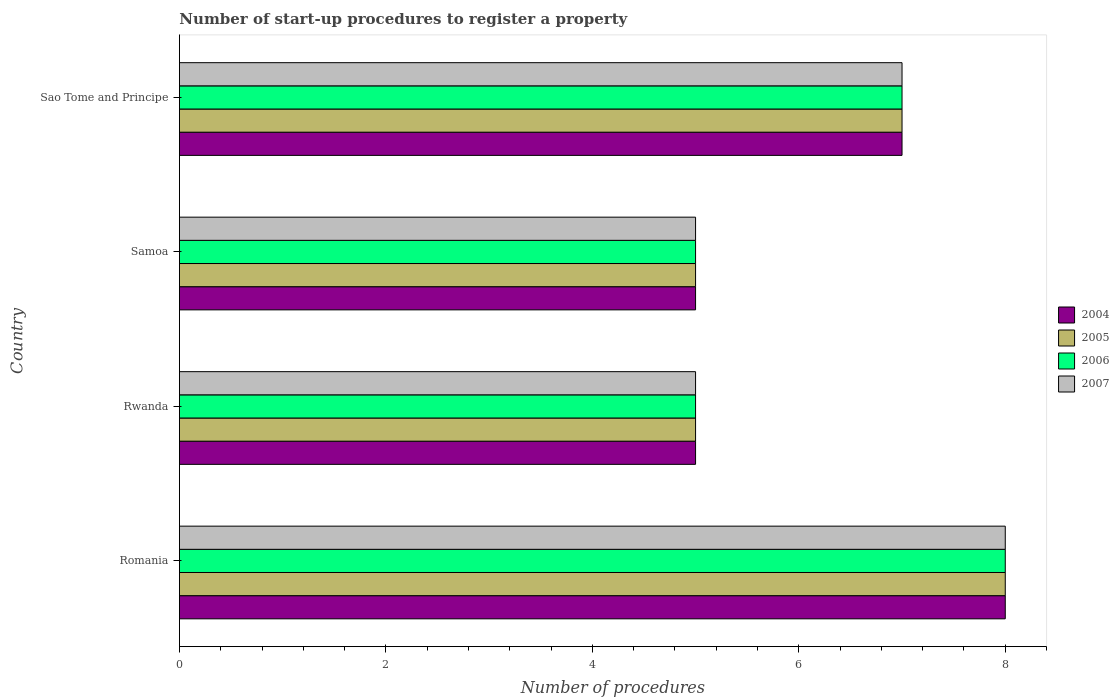How many different coloured bars are there?
Ensure brevity in your answer.  4. Are the number of bars on each tick of the Y-axis equal?
Make the answer very short. Yes. What is the label of the 4th group of bars from the top?
Give a very brief answer. Romania. Across all countries, what is the maximum number of procedures required to register a property in 2004?
Your answer should be compact. 8. Across all countries, what is the minimum number of procedures required to register a property in 2007?
Offer a very short reply. 5. In which country was the number of procedures required to register a property in 2004 maximum?
Give a very brief answer. Romania. In which country was the number of procedures required to register a property in 2007 minimum?
Keep it short and to the point. Rwanda. What is the total number of procedures required to register a property in 2005 in the graph?
Your answer should be compact. 25. What is the average number of procedures required to register a property in 2004 per country?
Your answer should be compact. 6.25. What is the difference between the number of procedures required to register a property in 2006 and number of procedures required to register a property in 2005 in Rwanda?
Give a very brief answer. 0. What is the ratio of the number of procedures required to register a property in 2004 in Romania to that in Sao Tome and Principe?
Provide a succinct answer. 1.14. Is it the case that in every country, the sum of the number of procedures required to register a property in 2004 and number of procedures required to register a property in 2005 is greater than the sum of number of procedures required to register a property in 2006 and number of procedures required to register a property in 2007?
Your answer should be compact. No. What does the 2nd bar from the top in Romania represents?
Offer a very short reply. 2006. What does the 1st bar from the bottom in Sao Tome and Principe represents?
Your response must be concise. 2004. Is it the case that in every country, the sum of the number of procedures required to register a property in 2005 and number of procedures required to register a property in 2004 is greater than the number of procedures required to register a property in 2006?
Make the answer very short. Yes. How many countries are there in the graph?
Provide a short and direct response. 4. What is the difference between two consecutive major ticks on the X-axis?
Provide a short and direct response. 2. Are the values on the major ticks of X-axis written in scientific E-notation?
Give a very brief answer. No. Does the graph contain any zero values?
Ensure brevity in your answer.  No. How are the legend labels stacked?
Give a very brief answer. Vertical. What is the title of the graph?
Your answer should be very brief. Number of start-up procedures to register a property. What is the label or title of the X-axis?
Ensure brevity in your answer.  Number of procedures. What is the Number of procedures of 2004 in Romania?
Ensure brevity in your answer.  8. What is the Number of procedures in 2005 in Romania?
Keep it short and to the point. 8. What is the Number of procedures of 2006 in Romania?
Offer a terse response. 8. What is the Number of procedures of 2006 in Rwanda?
Provide a short and direct response. 5. What is the Number of procedures of 2004 in Samoa?
Make the answer very short. 5. What is the Number of procedures in 2005 in Samoa?
Provide a short and direct response. 5. What is the Number of procedures of 2006 in Samoa?
Keep it short and to the point. 5. What is the Number of procedures in 2007 in Samoa?
Provide a short and direct response. 5. What is the Number of procedures of 2004 in Sao Tome and Principe?
Ensure brevity in your answer.  7. What is the Number of procedures of 2005 in Sao Tome and Principe?
Your answer should be very brief. 7. What is the Number of procedures in 2006 in Sao Tome and Principe?
Offer a terse response. 7. Across all countries, what is the maximum Number of procedures in 2004?
Make the answer very short. 8. Across all countries, what is the maximum Number of procedures in 2005?
Keep it short and to the point. 8. Across all countries, what is the minimum Number of procedures of 2006?
Provide a short and direct response. 5. What is the total Number of procedures of 2004 in the graph?
Keep it short and to the point. 25. What is the total Number of procedures in 2005 in the graph?
Your answer should be compact. 25. What is the difference between the Number of procedures in 2006 in Romania and that in Rwanda?
Ensure brevity in your answer.  3. What is the difference between the Number of procedures of 2007 in Romania and that in Rwanda?
Offer a terse response. 3. What is the difference between the Number of procedures of 2007 in Romania and that in Samoa?
Ensure brevity in your answer.  3. What is the difference between the Number of procedures of 2005 in Romania and that in Sao Tome and Principe?
Keep it short and to the point. 1. What is the difference between the Number of procedures in 2007 in Romania and that in Sao Tome and Principe?
Provide a succinct answer. 1. What is the difference between the Number of procedures of 2004 in Rwanda and that in Samoa?
Provide a short and direct response. 0. What is the difference between the Number of procedures of 2006 in Rwanda and that in Sao Tome and Principe?
Your answer should be very brief. -2. What is the difference between the Number of procedures in 2007 in Rwanda and that in Sao Tome and Principe?
Offer a very short reply. -2. What is the difference between the Number of procedures of 2004 in Samoa and that in Sao Tome and Principe?
Your answer should be very brief. -2. What is the difference between the Number of procedures in 2005 in Samoa and that in Sao Tome and Principe?
Your answer should be compact. -2. What is the difference between the Number of procedures of 2006 in Samoa and that in Sao Tome and Principe?
Provide a succinct answer. -2. What is the difference between the Number of procedures in 2007 in Samoa and that in Sao Tome and Principe?
Offer a terse response. -2. What is the difference between the Number of procedures of 2004 in Romania and the Number of procedures of 2005 in Rwanda?
Your answer should be very brief. 3. What is the difference between the Number of procedures of 2004 in Romania and the Number of procedures of 2006 in Samoa?
Offer a very short reply. 3. What is the difference between the Number of procedures of 2004 in Romania and the Number of procedures of 2007 in Samoa?
Make the answer very short. 3. What is the difference between the Number of procedures of 2005 in Romania and the Number of procedures of 2007 in Sao Tome and Principe?
Your answer should be compact. 1. What is the difference between the Number of procedures of 2006 in Romania and the Number of procedures of 2007 in Sao Tome and Principe?
Provide a succinct answer. 1. What is the difference between the Number of procedures of 2004 in Rwanda and the Number of procedures of 2005 in Samoa?
Provide a succinct answer. 0. What is the difference between the Number of procedures in 2004 in Rwanda and the Number of procedures in 2006 in Samoa?
Your answer should be very brief. 0. What is the difference between the Number of procedures in 2004 in Rwanda and the Number of procedures in 2006 in Sao Tome and Principe?
Your response must be concise. -2. What is the difference between the Number of procedures in 2005 in Rwanda and the Number of procedures in 2006 in Sao Tome and Principe?
Offer a terse response. -2. What is the difference between the Number of procedures of 2005 in Rwanda and the Number of procedures of 2007 in Sao Tome and Principe?
Offer a terse response. -2. What is the difference between the Number of procedures of 2004 in Samoa and the Number of procedures of 2005 in Sao Tome and Principe?
Your answer should be compact. -2. What is the difference between the Number of procedures in 2004 in Samoa and the Number of procedures in 2007 in Sao Tome and Principe?
Keep it short and to the point. -2. What is the difference between the Number of procedures in 2005 in Samoa and the Number of procedures in 2006 in Sao Tome and Principe?
Offer a very short reply. -2. What is the difference between the Number of procedures in 2005 in Samoa and the Number of procedures in 2007 in Sao Tome and Principe?
Your response must be concise. -2. What is the average Number of procedures of 2004 per country?
Your response must be concise. 6.25. What is the average Number of procedures in 2005 per country?
Provide a succinct answer. 6.25. What is the average Number of procedures in 2006 per country?
Your response must be concise. 6.25. What is the average Number of procedures in 2007 per country?
Provide a short and direct response. 6.25. What is the difference between the Number of procedures of 2004 and Number of procedures of 2005 in Romania?
Keep it short and to the point. 0. What is the difference between the Number of procedures of 2005 and Number of procedures of 2007 in Romania?
Keep it short and to the point. 0. What is the difference between the Number of procedures of 2006 and Number of procedures of 2007 in Romania?
Make the answer very short. 0. What is the difference between the Number of procedures in 2004 and Number of procedures in 2005 in Rwanda?
Provide a succinct answer. 0. What is the difference between the Number of procedures of 2004 and Number of procedures of 2006 in Rwanda?
Your response must be concise. 0. What is the difference between the Number of procedures of 2004 and Number of procedures of 2007 in Rwanda?
Keep it short and to the point. 0. What is the difference between the Number of procedures in 2005 and Number of procedures in 2006 in Rwanda?
Offer a terse response. 0. What is the difference between the Number of procedures of 2005 and Number of procedures of 2007 in Rwanda?
Provide a succinct answer. 0. What is the difference between the Number of procedures in 2004 and Number of procedures in 2007 in Samoa?
Make the answer very short. 0. What is the difference between the Number of procedures in 2005 and Number of procedures in 2006 in Samoa?
Provide a succinct answer. 0. What is the difference between the Number of procedures in 2005 and Number of procedures in 2007 in Samoa?
Your answer should be compact. 0. What is the difference between the Number of procedures of 2006 and Number of procedures of 2007 in Samoa?
Ensure brevity in your answer.  0. What is the difference between the Number of procedures in 2004 and Number of procedures in 2007 in Sao Tome and Principe?
Provide a succinct answer. 0. What is the difference between the Number of procedures in 2006 and Number of procedures in 2007 in Sao Tome and Principe?
Your answer should be very brief. 0. What is the ratio of the Number of procedures in 2004 in Romania to that in Rwanda?
Your response must be concise. 1.6. What is the ratio of the Number of procedures in 2007 in Romania to that in Rwanda?
Provide a short and direct response. 1.6. What is the ratio of the Number of procedures of 2004 in Romania to that in Samoa?
Provide a short and direct response. 1.6. What is the ratio of the Number of procedures of 2005 in Romania to that in Samoa?
Provide a succinct answer. 1.6. What is the ratio of the Number of procedures of 2006 in Romania to that in Samoa?
Provide a short and direct response. 1.6. What is the ratio of the Number of procedures of 2007 in Romania to that in Samoa?
Give a very brief answer. 1.6. What is the ratio of the Number of procedures of 2005 in Romania to that in Sao Tome and Principe?
Your answer should be very brief. 1.14. What is the ratio of the Number of procedures in 2006 in Rwanda to that in Samoa?
Provide a short and direct response. 1. What is the ratio of the Number of procedures of 2005 in Rwanda to that in Sao Tome and Principe?
Your response must be concise. 0.71. What is the ratio of the Number of procedures in 2006 in Rwanda to that in Sao Tome and Principe?
Provide a succinct answer. 0.71. What is the ratio of the Number of procedures in 2006 in Samoa to that in Sao Tome and Principe?
Give a very brief answer. 0.71. What is the ratio of the Number of procedures in 2007 in Samoa to that in Sao Tome and Principe?
Give a very brief answer. 0.71. What is the difference between the highest and the second highest Number of procedures of 2005?
Offer a terse response. 1. What is the difference between the highest and the second highest Number of procedures in 2007?
Your answer should be compact. 1. 